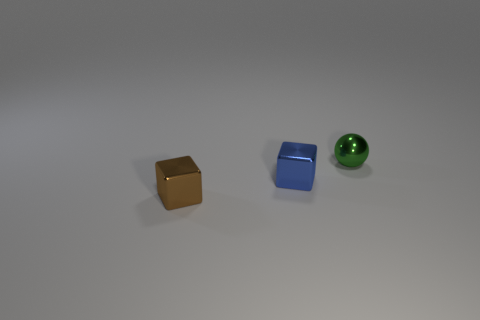There is a small green metallic sphere that is behind the brown metallic object; are there any small spheres left of it?
Your response must be concise. No. Does the green sphere have the same material as the blue thing?
Offer a very short reply. Yes. There is a metallic thing that is both on the right side of the brown metallic object and left of the small ball; what shape is it?
Ensure brevity in your answer.  Cube. What number of other small metallic things have the same shape as the blue metallic thing?
Give a very brief answer. 1. Are there any other things that are the same shape as the brown thing?
Your answer should be very brief. Yes. The tiny ball has what color?
Your response must be concise. Green. How many other objects are there of the same size as the green metallic ball?
Your response must be concise. 2. What number of brown blocks have the same material as the tiny sphere?
Keep it short and to the point. 1. What is the shape of the tiny blue metallic thing behind the small brown shiny block?
Offer a very short reply. Cube. Do the blue block and the tiny object that is on the right side of the blue metal block have the same material?
Offer a terse response. Yes. 